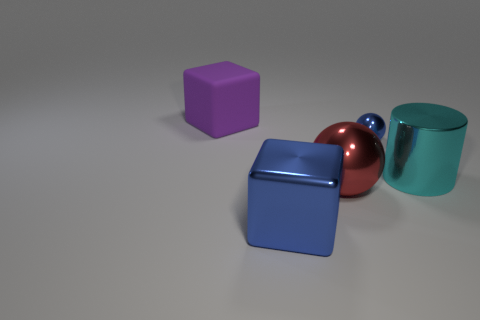Add 4 large gray metallic balls. How many objects exist? 9 Subtract 1 cubes. How many cubes are left? 1 Subtract all purple cubes. How many cubes are left? 1 Subtract all cylinders. How many objects are left? 4 Subtract all gray cylinders. How many blue blocks are left? 1 Add 2 tiny purple cubes. How many tiny purple cubes exist? 2 Subtract 0 gray blocks. How many objects are left? 5 Subtract all cyan cubes. Subtract all blue cylinders. How many cubes are left? 2 Subtract all red metallic cylinders. Subtract all blue things. How many objects are left? 3 Add 4 matte things. How many matte things are left? 5 